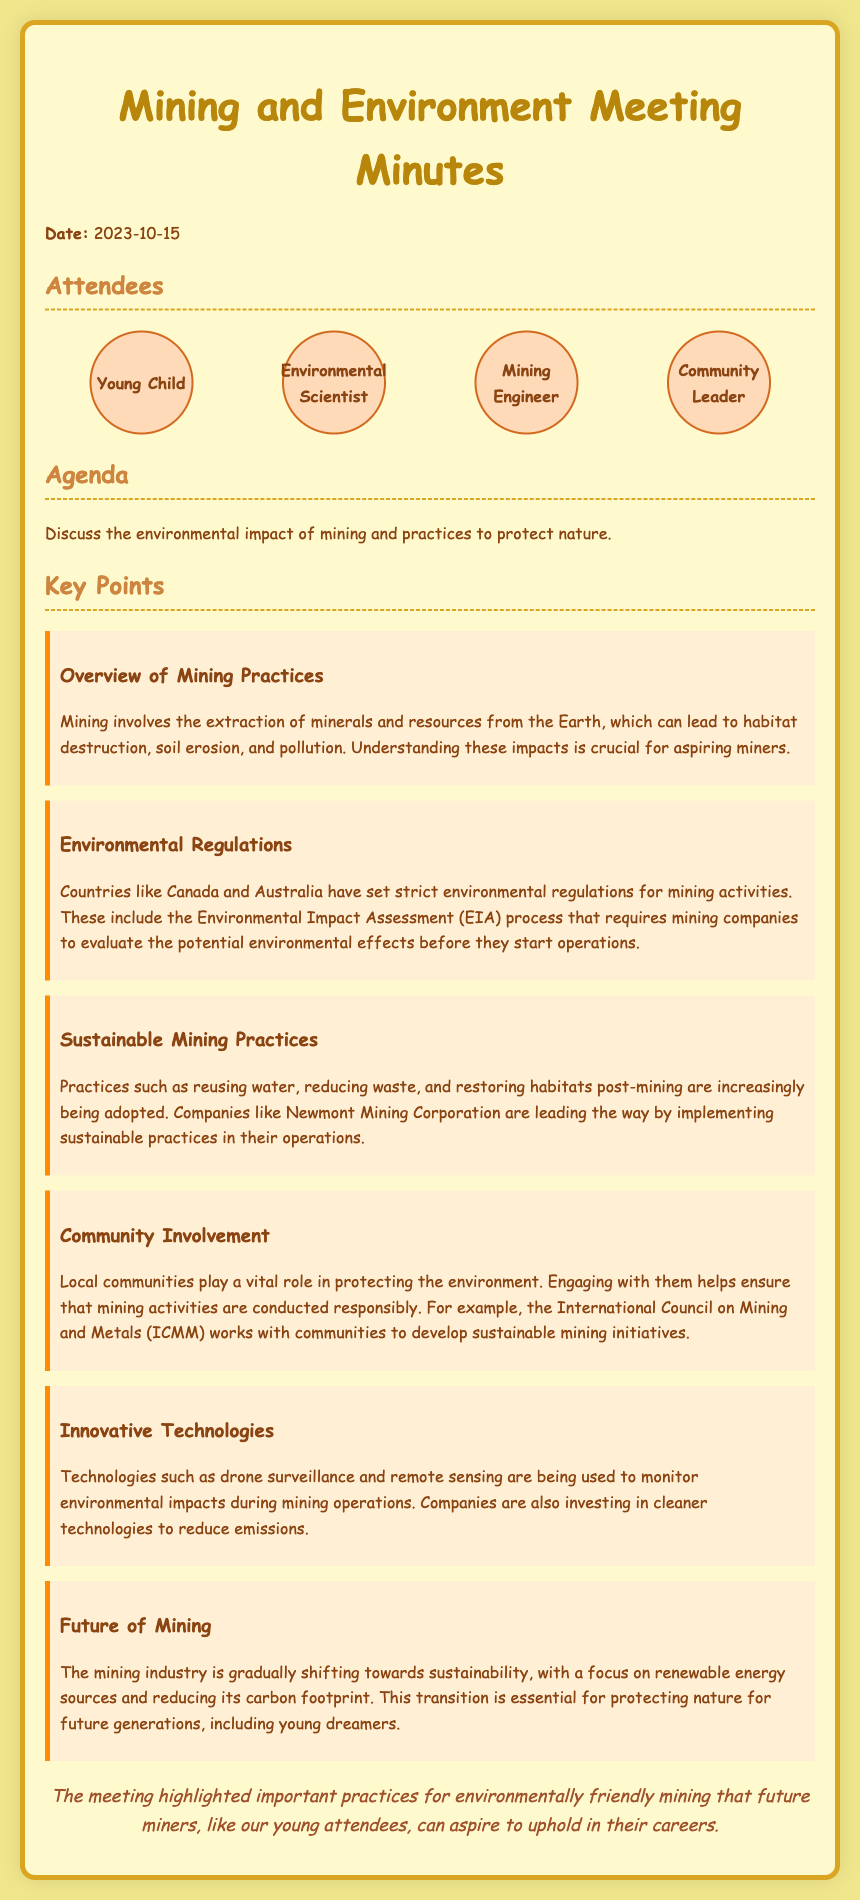What is the date of the meeting? The date of the meeting is mentioned at the beginning of the document.
Answer: 2023-10-15 Who attended the meeting as the environmental scientist? This question refers to one of the specific participants listed in the attendees section.
Answer: Environmental Scientist What is a practice adopted by mining companies to be more sustainable? The document lists several sustainable practices under key points.
Answer: Reusing water Which organization works with communities to develop sustainable mining initiatives? The document highlights specific organizations involved in community engagement.
Answer: International Council on Mining and Metals What kind of technologies are used to monitor environmental impacts? The document discusses technologies used in mining operations.
Answer: Drone surveillance What should aspiring miners understand about mining's impact? This question relates to the importance of knowledge concerning mining practices.
Answer: Habitat destruction Which countries have strict environmental regulations for mining? The key points section mentions specific countries with regulations.
Answer: Canada and Australia What is the focus of the future of mining according to the document? The future of mining is discussed towards the end of the key points.
Answer: Sustainability 